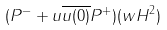<formula> <loc_0><loc_0><loc_500><loc_500>( P ^ { - } + u \overline { u ( 0 ) } P ^ { + } ) ( w H ^ { 2 } )</formula> 